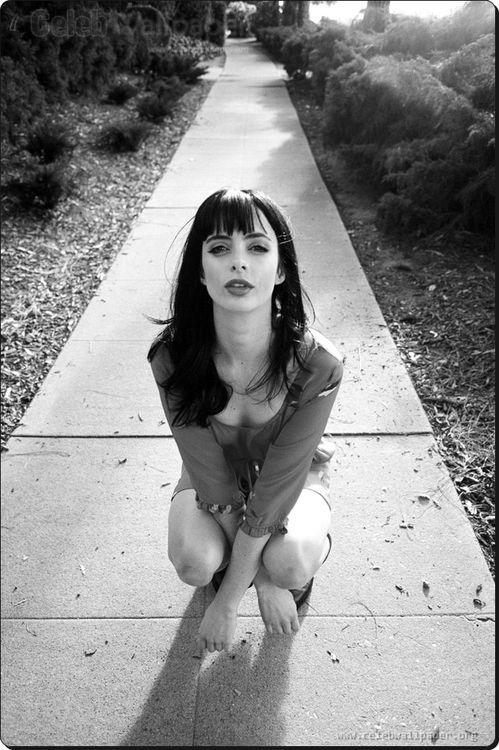What emotions do you think are being conveyed here? The image communicates a range of emotions. Her serious expression and direct gaze suggest determination, perhaps a hint of resolve. The kneeling posture could imply submission or vulnerability, adding a layer of complexity to her emotions, making the viewer ponder what might be on her mind. If this were a scene from a movie, what would be happening? If this were part of a movie, it might be a pivotal scene where the character is at a crossroads, making a crucial decision about her future. The setting could be a moment of clarity or realization, where she contemplates the consequences of her actions and decides to face the challenges ahead with courage. 